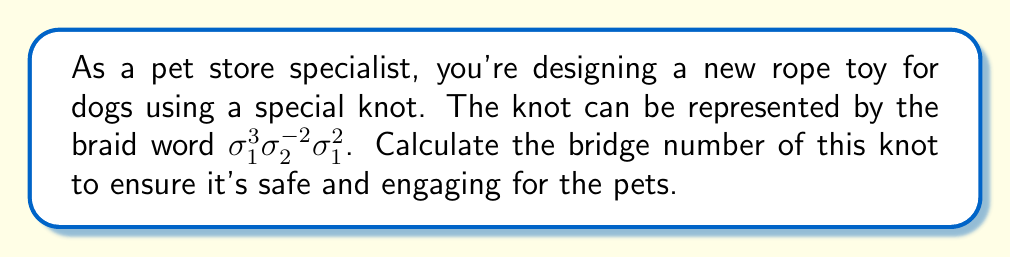Can you solve this math problem? To compute the bridge number of the knot represented by the braid word $\sigma_1^3\sigma_2^{-2}\sigma_1^2$, we'll follow these steps:

1) First, recall that for a braid with $n$ strands, the bridge number is at most $n$.

2) In this case, the braid word uses $\sigma_1$ and $\sigma_2$, which implies it's a 3-strand braid. So the bridge number is at most 3.

3) To determine if the bridge number is actually less than 3, we need to check if the knot is the unknot or a 2-bridge knot.

4) The braid word $\sigma_1^3\sigma_2^{-2}\sigma_1^2$ can be simplified:
   
   $\sigma_1^3\sigma_2^{-2}\sigma_1^2 = \sigma_1^5\sigma_2^{-2}$

5) This simplified braid word is not equivalent to the trivial braid, so the knot is not the unknot.

6) To check if it's a 2-bridge knot, we can use the fact that 2-bridge knots have a braid representation of the form $(\sigma_1\sigma_2^{-1})^n$ for some integer $n$.

7) Our braid word $\sigma_1^5\sigma_2^{-2}$ cannot be put into this form through braid moves.

Therefore, we conclude that the bridge number of this knot is 3.
Answer: 3 